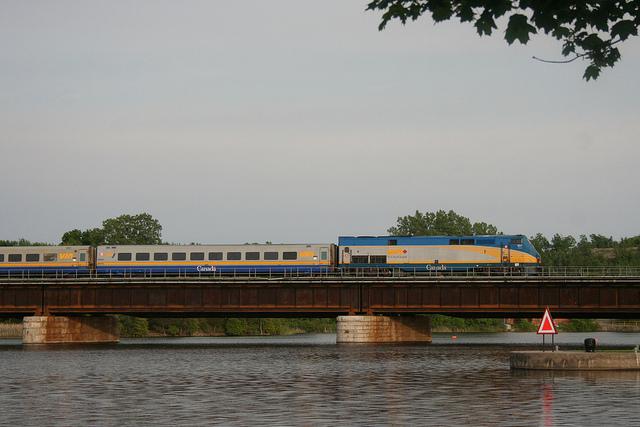Can the boats pass under the bridge?
Keep it brief. No. Is this on a lake?
Keep it brief. No. How many cars long is the train?
Keep it brief. 3. What kind of trees are these?
Short answer required. Maple. Is there a bird in the sky?
Be succinct. No. How many cars does the train have?
Be succinct. 3. How many people do you see?
Be succinct. 0. Is the train going over a river?
Answer briefly. Yes. Are cars allowed on the bridge in the background?
Give a very brief answer. No. Is the train in motion?
Keep it brief. Yes. What color is the water?
Concise answer only. Gray. What is advertised here?
Give a very brief answer. Train. 